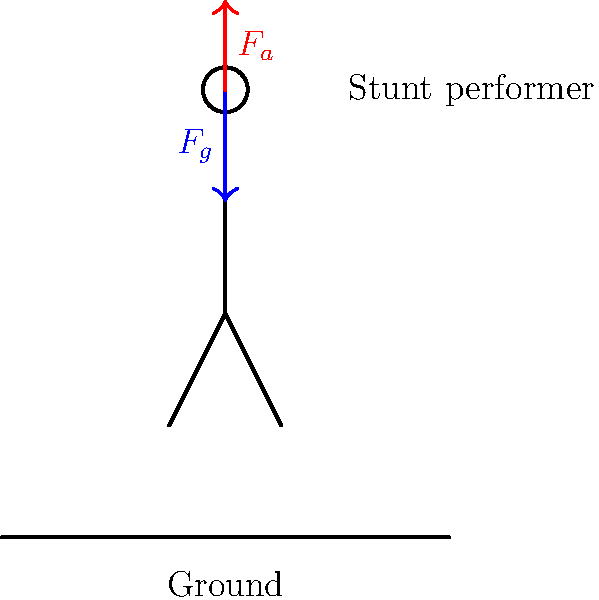In a high-fall stunt for an action sequence, a performer is falling from a significant height. Assuming the performer weighs 70 kg and reaches a terminal velocity of 50 m/s just before deploying their safety equipment, what is the magnitude of the air resistance force acting on the performer at this moment? To solve this problem, we need to follow these steps:

1. Recognize that at terminal velocity, the net force on the performer is zero. This means the upward force of air resistance ($F_a$) is equal to the downward force of gravity ($F_g$).

2. Calculate the force of gravity:
   $F_g = mg$, where $m$ is the mass and $g$ is the acceleration due to gravity (9.8 m/s²)
   $F_g = 70 \text{ kg} \times 9.8 \text{ m/s}^2 = 686 \text{ N}$

3. Since the performer has reached terminal velocity, the air resistance force must equal the force of gravity:
   $F_a = F_g = 686 \text{ N}$

Therefore, the magnitude of the air resistance force acting on the performer at terminal velocity is 686 N.

This calculation is crucial for a TV show producer to understand the forces involved in stunts, ensuring the safety of performers and the realism of action sequences.
Answer: 686 N 